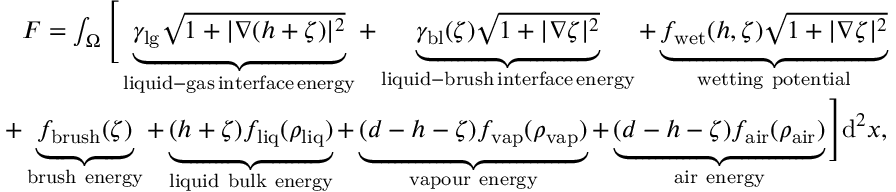Convert formula to latex. <formula><loc_0><loc_0><loc_500><loc_500>\begin{array} { r } { F = \int _ { \Omega } \left [ \underbrace { \gamma _ { l g } { \sqrt { 1 + | \nabla ( h + \zeta ) | ^ { 2 } } } } _ { l i q u i d - g a s \, i n t e r f a c e \, e n e r g y } + \underbrace { \gamma _ { b l } ( \zeta ) \sqrt { 1 + | \nabla \zeta | ^ { 2 } } } _ { l i q u i d - b r u s h \, i n t e r f a c e \, e n e r g y } + \underbrace { f _ { w e t } ( h , \zeta ) \sqrt { 1 + | \nabla \zeta | ^ { 2 } } } _ { w e t t i n g p o t e n t i a l } } \\ { + \underbrace { f _ { b r u s h } ( \zeta ) } _ { b r u s h e n e r g y } + \underbrace { ( h + \zeta ) f _ { l i q } ( \rho _ { l i q } ) } _ { l i q u i d b u l k e n e r g y } + \underbrace { ( d - h - \zeta ) f _ { v a p } ( \rho _ { v a p } ) } _ { v a p o u r e n e r g y } + \underbrace { ( d - h - \zeta ) f _ { a i r } ( \rho _ { a i r } ) } _ { a i r e n e r g y } \right ] d ^ { 2 } x , } \end{array}</formula> 